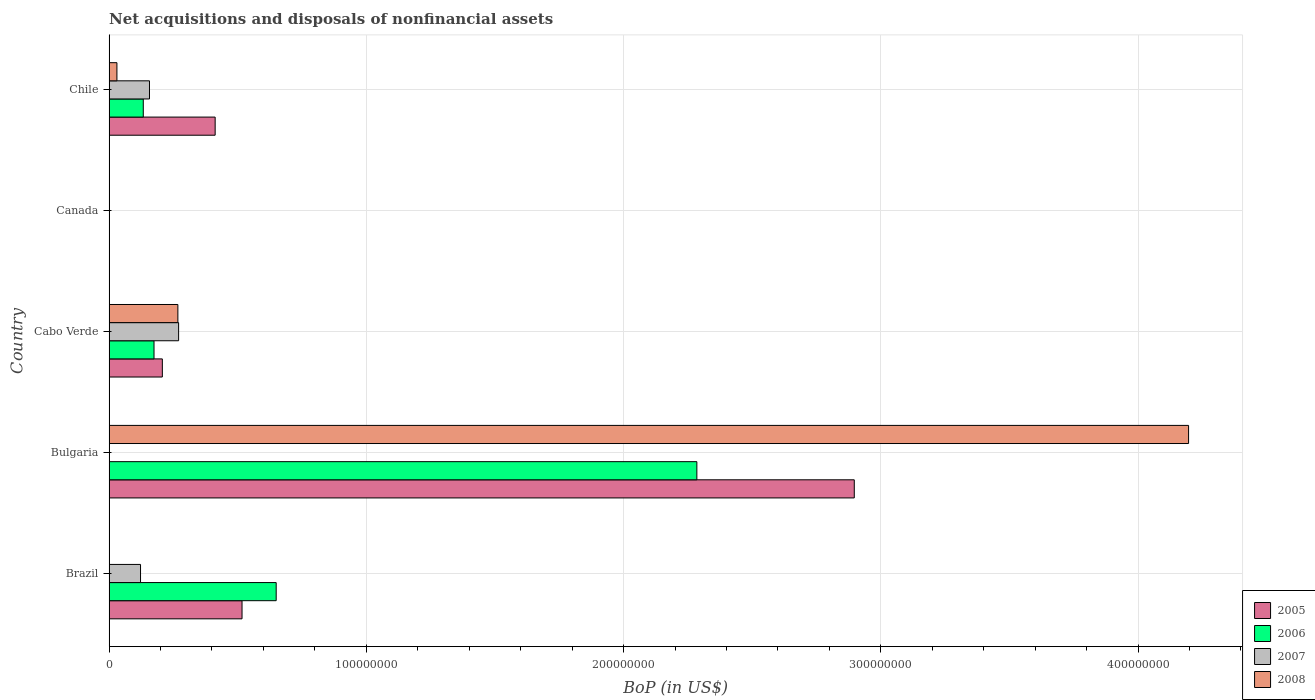How many different coloured bars are there?
Your answer should be very brief. 4. Are the number of bars per tick equal to the number of legend labels?
Make the answer very short. No. How many bars are there on the 1st tick from the bottom?
Your response must be concise. 3. In how many cases, is the number of bars for a given country not equal to the number of legend labels?
Ensure brevity in your answer.  3. What is the Balance of Payments in 2007 in Cabo Verde?
Keep it short and to the point. 2.70e+07. Across all countries, what is the maximum Balance of Payments in 2008?
Offer a terse response. 4.20e+08. Across all countries, what is the minimum Balance of Payments in 2007?
Make the answer very short. 0. In which country was the Balance of Payments in 2008 maximum?
Your answer should be compact. Bulgaria. What is the total Balance of Payments in 2005 in the graph?
Offer a terse response. 4.03e+08. What is the difference between the Balance of Payments in 2006 in Brazil and that in Bulgaria?
Keep it short and to the point. -1.64e+08. What is the difference between the Balance of Payments in 2007 in Cabo Verde and the Balance of Payments in 2005 in Canada?
Make the answer very short. 2.70e+07. What is the average Balance of Payments in 2006 per country?
Provide a short and direct response. 6.48e+07. What is the difference between the Balance of Payments in 2005 and Balance of Payments in 2008 in Bulgaria?
Keep it short and to the point. -1.30e+08. In how many countries, is the Balance of Payments in 2006 greater than 400000000 US$?
Offer a very short reply. 0. What is the ratio of the Balance of Payments in 2007 in Brazil to that in Cabo Verde?
Your answer should be very brief. 0.45. What is the difference between the highest and the second highest Balance of Payments in 2006?
Give a very brief answer. 1.64e+08. What is the difference between the highest and the lowest Balance of Payments in 2005?
Offer a very short reply. 2.90e+08. Is it the case that in every country, the sum of the Balance of Payments in 2005 and Balance of Payments in 2007 is greater than the Balance of Payments in 2006?
Keep it short and to the point. No. How many countries are there in the graph?
Provide a succinct answer. 5. Does the graph contain any zero values?
Provide a succinct answer. Yes. Does the graph contain grids?
Ensure brevity in your answer.  Yes. How are the legend labels stacked?
Provide a succinct answer. Vertical. What is the title of the graph?
Provide a succinct answer. Net acquisitions and disposals of nonfinancial assets. Does "1990" appear as one of the legend labels in the graph?
Give a very brief answer. No. What is the label or title of the X-axis?
Offer a very short reply. BoP (in US$). What is the label or title of the Y-axis?
Your response must be concise. Country. What is the BoP (in US$) in 2005 in Brazil?
Your answer should be compact. 5.17e+07. What is the BoP (in US$) of 2006 in Brazil?
Offer a very short reply. 6.50e+07. What is the BoP (in US$) of 2007 in Brazil?
Make the answer very short. 1.22e+07. What is the BoP (in US$) of 2008 in Brazil?
Your answer should be compact. 0. What is the BoP (in US$) of 2005 in Bulgaria?
Your answer should be very brief. 2.90e+08. What is the BoP (in US$) of 2006 in Bulgaria?
Keep it short and to the point. 2.28e+08. What is the BoP (in US$) in 2007 in Bulgaria?
Give a very brief answer. 0. What is the BoP (in US$) of 2008 in Bulgaria?
Offer a very short reply. 4.20e+08. What is the BoP (in US$) in 2005 in Cabo Verde?
Give a very brief answer. 2.07e+07. What is the BoP (in US$) in 2006 in Cabo Verde?
Your answer should be very brief. 1.75e+07. What is the BoP (in US$) of 2007 in Cabo Verde?
Your response must be concise. 2.70e+07. What is the BoP (in US$) of 2008 in Cabo Verde?
Offer a terse response. 2.67e+07. What is the BoP (in US$) in 2007 in Canada?
Provide a short and direct response. 0. What is the BoP (in US$) in 2008 in Canada?
Your answer should be very brief. 0. What is the BoP (in US$) in 2005 in Chile?
Give a very brief answer. 4.12e+07. What is the BoP (in US$) of 2006 in Chile?
Make the answer very short. 1.33e+07. What is the BoP (in US$) in 2007 in Chile?
Your answer should be compact. 1.57e+07. What is the BoP (in US$) of 2008 in Chile?
Make the answer very short. 3.06e+06. Across all countries, what is the maximum BoP (in US$) of 2005?
Offer a very short reply. 2.90e+08. Across all countries, what is the maximum BoP (in US$) of 2006?
Your response must be concise. 2.28e+08. Across all countries, what is the maximum BoP (in US$) of 2007?
Your response must be concise. 2.70e+07. Across all countries, what is the maximum BoP (in US$) of 2008?
Give a very brief answer. 4.20e+08. Across all countries, what is the minimum BoP (in US$) in 2007?
Offer a terse response. 0. Across all countries, what is the minimum BoP (in US$) in 2008?
Give a very brief answer. 0. What is the total BoP (in US$) of 2005 in the graph?
Keep it short and to the point. 4.03e+08. What is the total BoP (in US$) in 2006 in the graph?
Ensure brevity in your answer.  3.24e+08. What is the total BoP (in US$) in 2007 in the graph?
Keep it short and to the point. 5.50e+07. What is the total BoP (in US$) in 2008 in the graph?
Make the answer very short. 4.49e+08. What is the difference between the BoP (in US$) of 2005 in Brazil and that in Bulgaria?
Your answer should be compact. -2.38e+08. What is the difference between the BoP (in US$) of 2006 in Brazil and that in Bulgaria?
Your response must be concise. -1.64e+08. What is the difference between the BoP (in US$) in 2005 in Brazil and that in Cabo Verde?
Your answer should be very brief. 3.10e+07. What is the difference between the BoP (in US$) in 2006 in Brazil and that in Cabo Verde?
Keep it short and to the point. 4.75e+07. What is the difference between the BoP (in US$) of 2007 in Brazil and that in Cabo Verde?
Offer a very short reply. -1.48e+07. What is the difference between the BoP (in US$) in 2005 in Brazil and that in Chile?
Provide a succinct answer. 1.04e+07. What is the difference between the BoP (in US$) in 2006 in Brazil and that in Chile?
Offer a terse response. 5.17e+07. What is the difference between the BoP (in US$) of 2007 in Brazil and that in Chile?
Give a very brief answer. -3.48e+06. What is the difference between the BoP (in US$) in 2005 in Bulgaria and that in Cabo Verde?
Make the answer very short. 2.69e+08. What is the difference between the BoP (in US$) of 2006 in Bulgaria and that in Cabo Verde?
Your response must be concise. 2.11e+08. What is the difference between the BoP (in US$) of 2008 in Bulgaria and that in Cabo Verde?
Your answer should be compact. 3.93e+08. What is the difference between the BoP (in US$) of 2005 in Bulgaria and that in Chile?
Ensure brevity in your answer.  2.48e+08. What is the difference between the BoP (in US$) in 2006 in Bulgaria and that in Chile?
Ensure brevity in your answer.  2.15e+08. What is the difference between the BoP (in US$) in 2008 in Bulgaria and that in Chile?
Ensure brevity in your answer.  4.17e+08. What is the difference between the BoP (in US$) in 2005 in Cabo Verde and that in Chile?
Ensure brevity in your answer.  -2.05e+07. What is the difference between the BoP (in US$) in 2006 in Cabo Verde and that in Chile?
Make the answer very short. 4.17e+06. What is the difference between the BoP (in US$) in 2007 in Cabo Verde and that in Chile?
Your answer should be compact. 1.13e+07. What is the difference between the BoP (in US$) of 2008 in Cabo Verde and that in Chile?
Keep it short and to the point. 2.37e+07. What is the difference between the BoP (in US$) in 2005 in Brazil and the BoP (in US$) in 2006 in Bulgaria?
Give a very brief answer. -1.77e+08. What is the difference between the BoP (in US$) of 2005 in Brazil and the BoP (in US$) of 2008 in Bulgaria?
Your response must be concise. -3.68e+08. What is the difference between the BoP (in US$) of 2006 in Brazil and the BoP (in US$) of 2008 in Bulgaria?
Provide a short and direct response. -3.55e+08. What is the difference between the BoP (in US$) in 2007 in Brazil and the BoP (in US$) in 2008 in Bulgaria?
Make the answer very short. -4.07e+08. What is the difference between the BoP (in US$) of 2005 in Brazil and the BoP (in US$) of 2006 in Cabo Verde?
Offer a terse response. 3.42e+07. What is the difference between the BoP (in US$) in 2005 in Brazil and the BoP (in US$) in 2007 in Cabo Verde?
Your answer should be compact. 2.47e+07. What is the difference between the BoP (in US$) of 2005 in Brazil and the BoP (in US$) of 2008 in Cabo Verde?
Make the answer very short. 2.49e+07. What is the difference between the BoP (in US$) in 2006 in Brazil and the BoP (in US$) in 2007 in Cabo Verde?
Give a very brief answer. 3.79e+07. What is the difference between the BoP (in US$) of 2006 in Brazil and the BoP (in US$) of 2008 in Cabo Verde?
Your response must be concise. 3.82e+07. What is the difference between the BoP (in US$) of 2007 in Brazil and the BoP (in US$) of 2008 in Cabo Verde?
Ensure brevity in your answer.  -1.45e+07. What is the difference between the BoP (in US$) of 2005 in Brazil and the BoP (in US$) of 2006 in Chile?
Ensure brevity in your answer.  3.84e+07. What is the difference between the BoP (in US$) of 2005 in Brazil and the BoP (in US$) of 2007 in Chile?
Your answer should be very brief. 3.60e+07. What is the difference between the BoP (in US$) of 2005 in Brazil and the BoP (in US$) of 2008 in Chile?
Make the answer very short. 4.86e+07. What is the difference between the BoP (in US$) of 2006 in Brazil and the BoP (in US$) of 2007 in Chile?
Offer a very short reply. 4.93e+07. What is the difference between the BoP (in US$) of 2006 in Brazil and the BoP (in US$) of 2008 in Chile?
Give a very brief answer. 6.19e+07. What is the difference between the BoP (in US$) of 2007 in Brazil and the BoP (in US$) of 2008 in Chile?
Provide a succinct answer. 9.17e+06. What is the difference between the BoP (in US$) of 2005 in Bulgaria and the BoP (in US$) of 2006 in Cabo Verde?
Offer a terse response. 2.72e+08. What is the difference between the BoP (in US$) of 2005 in Bulgaria and the BoP (in US$) of 2007 in Cabo Verde?
Keep it short and to the point. 2.63e+08. What is the difference between the BoP (in US$) of 2005 in Bulgaria and the BoP (in US$) of 2008 in Cabo Verde?
Your response must be concise. 2.63e+08. What is the difference between the BoP (in US$) in 2006 in Bulgaria and the BoP (in US$) in 2007 in Cabo Verde?
Keep it short and to the point. 2.01e+08. What is the difference between the BoP (in US$) in 2006 in Bulgaria and the BoP (in US$) in 2008 in Cabo Verde?
Give a very brief answer. 2.02e+08. What is the difference between the BoP (in US$) of 2005 in Bulgaria and the BoP (in US$) of 2006 in Chile?
Your answer should be very brief. 2.76e+08. What is the difference between the BoP (in US$) in 2005 in Bulgaria and the BoP (in US$) in 2007 in Chile?
Give a very brief answer. 2.74e+08. What is the difference between the BoP (in US$) of 2005 in Bulgaria and the BoP (in US$) of 2008 in Chile?
Provide a short and direct response. 2.87e+08. What is the difference between the BoP (in US$) in 2006 in Bulgaria and the BoP (in US$) in 2007 in Chile?
Offer a terse response. 2.13e+08. What is the difference between the BoP (in US$) of 2006 in Bulgaria and the BoP (in US$) of 2008 in Chile?
Your response must be concise. 2.25e+08. What is the difference between the BoP (in US$) in 2005 in Cabo Verde and the BoP (in US$) in 2006 in Chile?
Keep it short and to the point. 7.41e+06. What is the difference between the BoP (in US$) in 2005 in Cabo Verde and the BoP (in US$) in 2007 in Chile?
Ensure brevity in your answer.  5.00e+06. What is the difference between the BoP (in US$) in 2005 in Cabo Verde and the BoP (in US$) in 2008 in Chile?
Provide a short and direct response. 1.77e+07. What is the difference between the BoP (in US$) of 2006 in Cabo Verde and the BoP (in US$) of 2007 in Chile?
Your answer should be compact. 1.76e+06. What is the difference between the BoP (in US$) in 2006 in Cabo Verde and the BoP (in US$) in 2008 in Chile?
Provide a short and direct response. 1.44e+07. What is the difference between the BoP (in US$) in 2007 in Cabo Verde and the BoP (in US$) in 2008 in Chile?
Provide a succinct answer. 2.40e+07. What is the average BoP (in US$) of 2005 per country?
Offer a very short reply. 8.07e+07. What is the average BoP (in US$) in 2006 per country?
Your answer should be very brief. 6.48e+07. What is the average BoP (in US$) in 2007 per country?
Give a very brief answer. 1.10e+07. What is the average BoP (in US$) of 2008 per country?
Offer a terse response. 8.99e+07. What is the difference between the BoP (in US$) in 2005 and BoP (in US$) in 2006 in Brazil?
Offer a very short reply. -1.33e+07. What is the difference between the BoP (in US$) of 2005 and BoP (in US$) of 2007 in Brazil?
Your answer should be compact. 3.95e+07. What is the difference between the BoP (in US$) of 2006 and BoP (in US$) of 2007 in Brazil?
Provide a succinct answer. 5.27e+07. What is the difference between the BoP (in US$) of 2005 and BoP (in US$) of 2006 in Bulgaria?
Provide a short and direct response. 6.12e+07. What is the difference between the BoP (in US$) in 2005 and BoP (in US$) in 2008 in Bulgaria?
Your answer should be very brief. -1.30e+08. What is the difference between the BoP (in US$) in 2006 and BoP (in US$) in 2008 in Bulgaria?
Ensure brevity in your answer.  -1.91e+08. What is the difference between the BoP (in US$) of 2005 and BoP (in US$) of 2006 in Cabo Verde?
Your answer should be compact. 3.24e+06. What is the difference between the BoP (in US$) in 2005 and BoP (in US$) in 2007 in Cabo Verde?
Keep it short and to the point. -6.32e+06. What is the difference between the BoP (in US$) of 2005 and BoP (in US$) of 2008 in Cabo Verde?
Ensure brevity in your answer.  -6.04e+06. What is the difference between the BoP (in US$) in 2006 and BoP (in US$) in 2007 in Cabo Verde?
Your answer should be compact. -9.56e+06. What is the difference between the BoP (in US$) in 2006 and BoP (in US$) in 2008 in Cabo Verde?
Offer a very short reply. -9.28e+06. What is the difference between the BoP (in US$) in 2007 and BoP (in US$) in 2008 in Cabo Verde?
Offer a very short reply. 2.85e+05. What is the difference between the BoP (in US$) of 2005 and BoP (in US$) of 2006 in Chile?
Offer a very short reply. 2.79e+07. What is the difference between the BoP (in US$) of 2005 and BoP (in US$) of 2007 in Chile?
Give a very brief answer. 2.55e+07. What is the difference between the BoP (in US$) of 2005 and BoP (in US$) of 2008 in Chile?
Ensure brevity in your answer.  3.82e+07. What is the difference between the BoP (in US$) in 2006 and BoP (in US$) in 2007 in Chile?
Keep it short and to the point. -2.41e+06. What is the difference between the BoP (in US$) in 2006 and BoP (in US$) in 2008 in Chile?
Keep it short and to the point. 1.02e+07. What is the difference between the BoP (in US$) of 2007 and BoP (in US$) of 2008 in Chile?
Keep it short and to the point. 1.27e+07. What is the ratio of the BoP (in US$) in 2005 in Brazil to that in Bulgaria?
Provide a short and direct response. 0.18. What is the ratio of the BoP (in US$) of 2006 in Brazil to that in Bulgaria?
Make the answer very short. 0.28. What is the ratio of the BoP (in US$) of 2005 in Brazil to that in Cabo Verde?
Your answer should be compact. 2.5. What is the ratio of the BoP (in US$) in 2006 in Brazil to that in Cabo Verde?
Offer a very short reply. 3.72. What is the ratio of the BoP (in US$) in 2007 in Brazil to that in Cabo Verde?
Your answer should be compact. 0.45. What is the ratio of the BoP (in US$) in 2005 in Brazil to that in Chile?
Offer a terse response. 1.25. What is the ratio of the BoP (in US$) in 2006 in Brazil to that in Chile?
Give a very brief answer. 4.88. What is the ratio of the BoP (in US$) in 2007 in Brazil to that in Chile?
Your answer should be very brief. 0.78. What is the ratio of the BoP (in US$) of 2005 in Bulgaria to that in Cabo Verde?
Offer a terse response. 13.99. What is the ratio of the BoP (in US$) in 2006 in Bulgaria to that in Cabo Verde?
Provide a short and direct response. 13.08. What is the ratio of the BoP (in US$) in 2008 in Bulgaria to that in Cabo Verde?
Give a very brief answer. 15.69. What is the ratio of the BoP (in US$) of 2005 in Bulgaria to that in Chile?
Provide a short and direct response. 7.02. What is the ratio of the BoP (in US$) of 2006 in Bulgaria to that in Chile?
Ensure brevity in your answer.  17.18. What is the ratio of the BoP (in US$) in 2008 in Bulgaria to that in Chile?
Your answer should be very brief. 137.31. What is the ratio of the BoP (in US$) of 2005 in Cabo Verde to that in Chile?
Your answer should be very brief. 0.5. What is the ratio of the BoP (in US$) of 2006 in Cabo Verde to that in Chile?
Offer a very short reply. 1.31. What is the ratio of the BoP (in US$) in 2007 in Cabo Verde to that in Chile?
Provide a short and direct response. 1.72. What is the ratio of the BoP (in US$) of 2008 in Cabo Verde to that in Chile?
Offer a very short reply. 8.75. What is the difference between the highest and the second highest BoP (in US$) in 2005?
Make the answer very short. 2.38e+08. What is the difference between the highest and the second highest BoP (in US$) in 2006?
Your response must be concise. 1.64e+08. What is the difference between the highest and the second highest BoP (in US$) of 2007?
Ensure brevity in your answer.  1.13e+07. What is the difference between the highest and the second highest BoP (in US$) in 2008?
Keep it short and to the point. 3.93e+08. What is the difference between the highest and the lowest BoP (in US$) in 2005?
Your answer should be compact. 2.90e+08. What is the difference between the highest and the lowest BoP (in US$) of 2006?
Offer a terse response. 2.28e+08. What is the difference between the highest and the lowest BoP (in US$) of 2007?
Your response must be concise. 2.70e+07. What is the difference between the highest and the lowest BoP (in US$) of 2008?
Your answer should be very brief. 4.20e+08. 